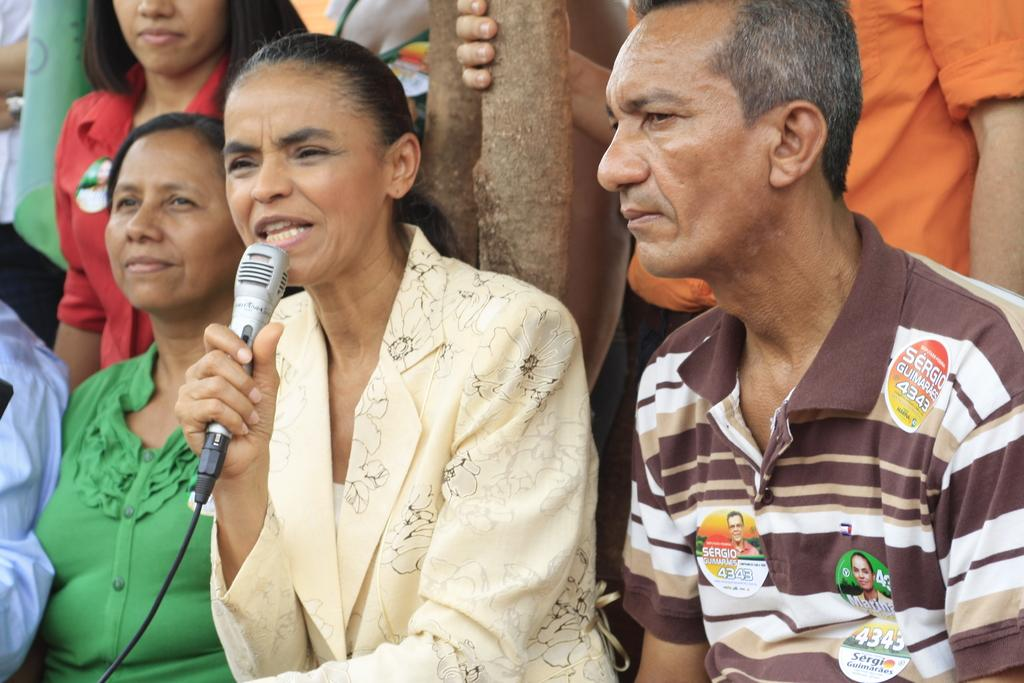How many people are present in the image? There are three people in the image. What is the lady holding in the image? The lady is holding a microphone. What can be seen on the guy's t-shirt? The guy has stickers on his t-shirt. What type of fruit is being used as a prop in the image? There is no fruit present in the image. What kind of beef dish is being prepared in the image? There is no beef dish or any food preparation visible in the image. 